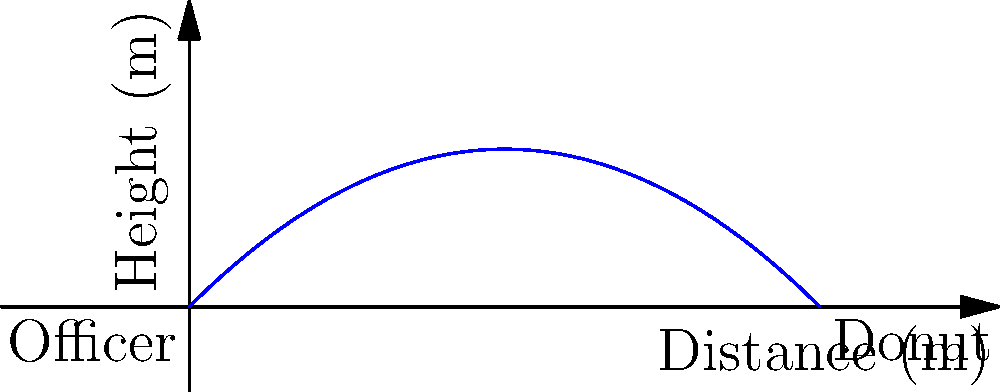Officer Sprinkles decides to toss a donut to his partner across the street. He throws the donut with an initial velocity of 10 m/s at a 45-degree angle from the ground. Assuming no air resistance, what is the maximum height the donut reaches during its flight? (Use g = 9.8 m/s^2 for acceleration due to gravity) To find the maximum height of the donut's trajectory, we'll follow these steps:

1. Identify the relevant equations:
   - Vertical motion: $y = v_0 \sin(\theta) t - \frac{1}{2}gt^2$
   - Time to reach maximum height: $t_{max} = \frac{v_0 \sin(\theta)}{g}$

2. Given information:
   - Initial velocity: $v_0 = 10$ m/s
   - Angle: $\theta = 45°$ (or $\frac{\pi}{4}$ radians)
   - Acceleration due to gravity: $g = 9.8$ m/s^2

3. Calculate the time to reach maximum height:
   $t_{max} = \frac{10 \sin(45°)}{9.8} = \frac{10 \cdot \frac{\sqrt{2}}{2}}{9.8} \approx 0.72$ seconds

4. Use the vertical motion equation to find the maximum height:
   $y_{max} = v_0 \sin(\theta) t_{max} - \frac{1}{2}g(t_{max})^2$

5. Substitute the values:
   $y_{max} = 10 \sin(45°) \cdot 0.72 - \frac{1}{2} \cdot 9.8 \cdot (0.72)^2$

6. Calculate the result:
   $y_{max} = 10 \cdot \frac{\sqrt{2}}{2} \cdot 0.72 - \frac{1}{2} \cdot 9.8 \cdot 0.5184$
   $y_{max} = 5.09 - 2.54 = 2.55$ meters

Therefore, the maximum height reached by the donut is approximately 2.55 meters.
Answer: 2.55 meters 